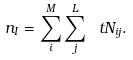<formula> <loc_0><loc_0><loc_500><loc_500>n _ { I } = \sum _ { i } ^ { M } \sum _ { j } ^ { L } \ t N _ { i j } .</formula> 